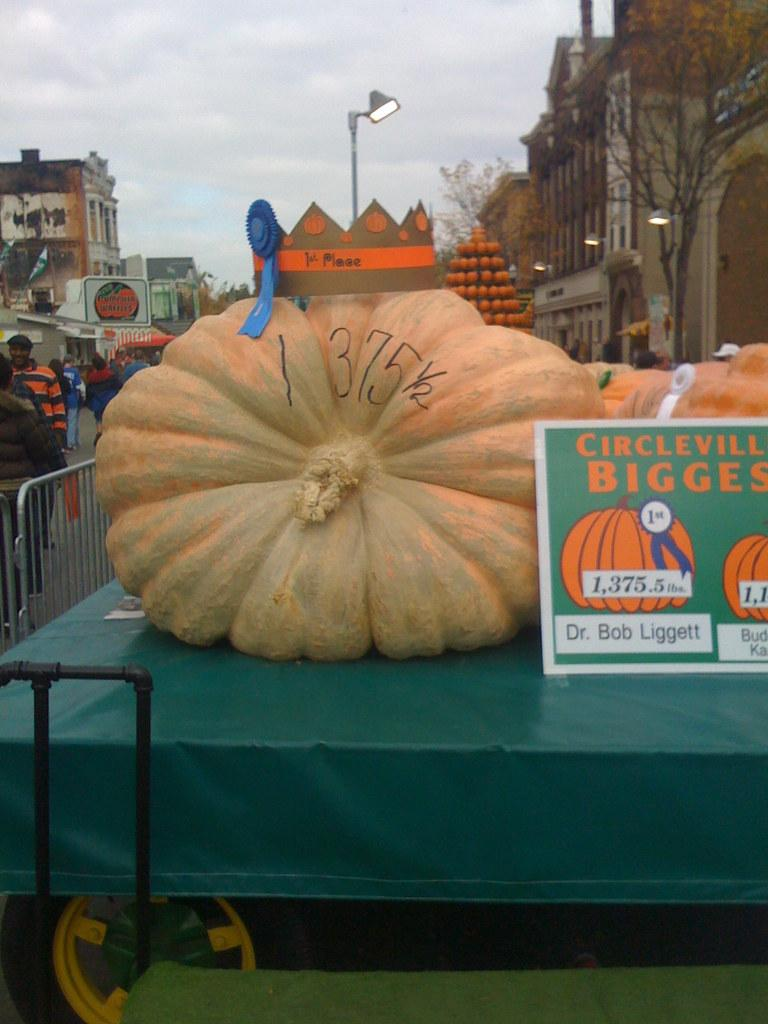What is the main subject in the center of the image? There is a pumpkin in the center of the image. Where is the pumpkin located? The pumpkin is on a vehicle. What can be seen in the background of the image? There are buildings, persons, a road, trees, and the sky visible in the background of the image. What is the condition of the sky in the image? The sky is visible in the background of the image, and there are clouds present. What type of snow can be seen falling on the road in the image? There is no snow present in the image; it features a pumpkin on a vehicle with a clear sky in the background. 